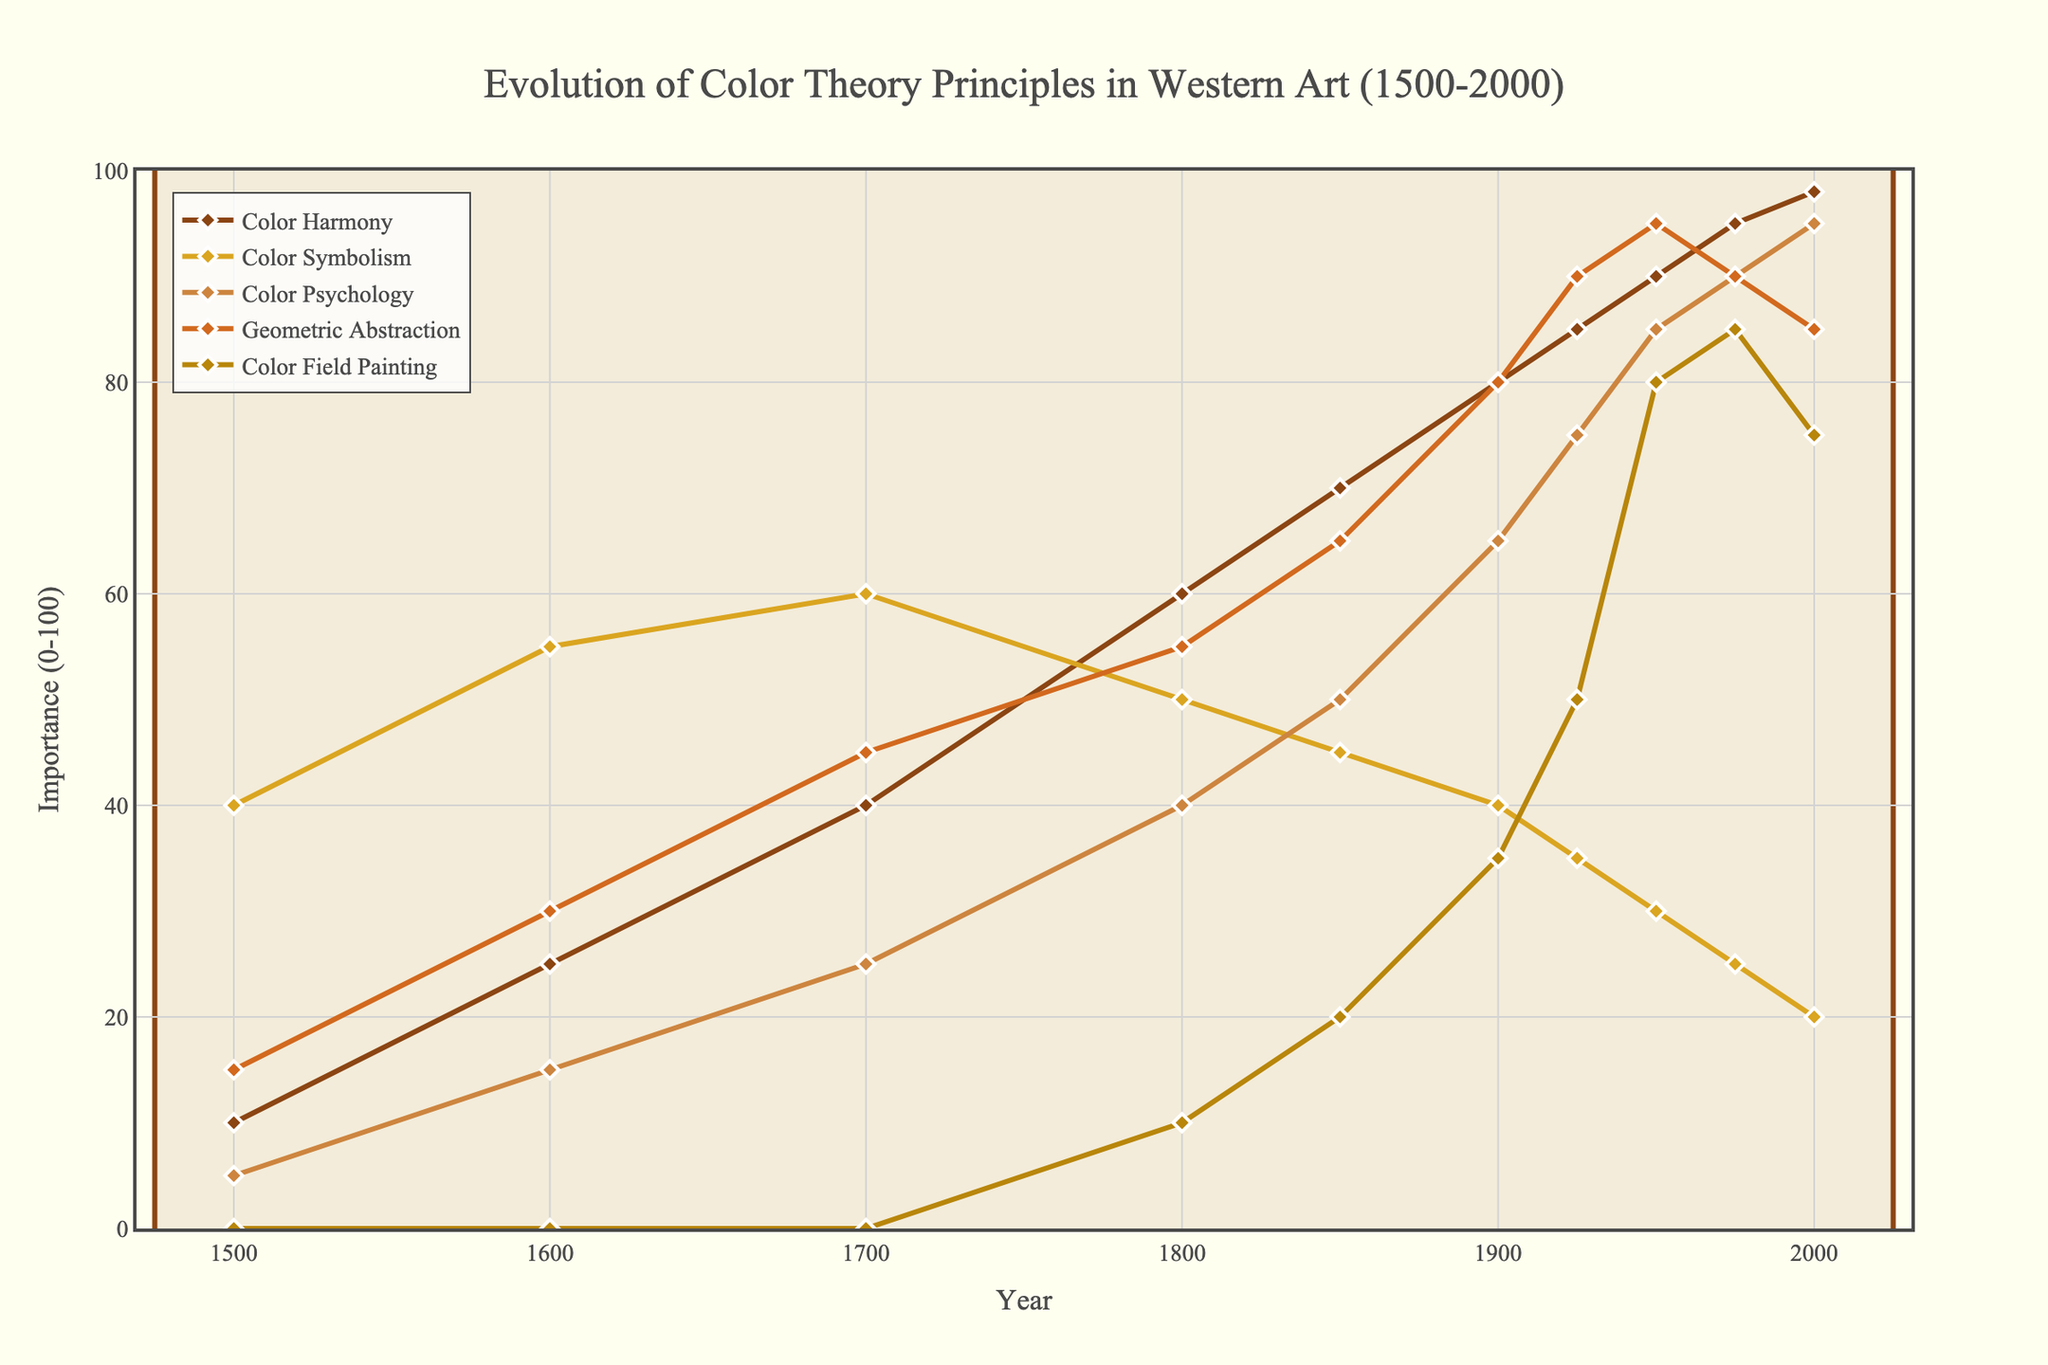What is the earliest year when Color Harmony was more important than Color Symbolism? We need to compare the values of "Color Harmony" and "Color Symbolism" over the years and determine the first instance where Color Harmony surpasses Color Symbolism. According to the figure, Color Harmony first surpasses Color Symbolism in 1800.
Answer: 1800 What was the importance of Geometric Abstraction in 1950? We can simply look at the value of Geometric Abstraction in the year 1950 on the line chart. The value is 95.
Answer: 95 By how much did Color Psychology increase from 1500 to 2000? We need to find the difference between the value of Color Psychology in 2000 and 1500. The values are 95 and 5 respectively. The increase = 95 - 5 = 90.
Answer: 90 Which color theory principle had the highest importance in 1925? Reviewing the chart, the highest point in 1925 is Color Harmony with a value of 85.
Answer: Color Harmony Compare the trend of Color Field Painting and Geometric Abstraction from 1900 to 2000. Which one increased more rapidly? To determine which one increased more rapidly, we observe the gradient of their lines. Color Field Painting starts at 35 and ends at 75, while Geometric Abstraction starts at 80 and ends at 85. The increase in Color Field Painting is 75 - 35 = 40, whereas Geometric Abstraction rises by 85 - 80 = 5. Hence, Color Field Painting increased more rapidly.
Answer: Color Field Painting What was the significance of Color Harmony and Color Psychology in 1600 combined? We sum the importance values of Color Harmony and Color Psychology in 1600. According to the figure, the values are 25 and 15 respectively. The combined significance = 25 + 15 = 40.
Answer: 40 Which principle shows a relative decline in importance from 1800 to 2000? Observing the line chart, we see that Color Symbolism's importance decreases from 50 in 1800 to 20 in 2000.
Answer: Color Symbolism Identify the year when Color Field Painting reaches its maximum importance. The peak of Color Field Painting is in 1975 with a value of 85.
Answer: 1975 What is the average importance of Geometric Abstraction across all measured years? To determine the average, sum all values for Geometric Abstraction and divide by the number of years. The values are 15, 30, 45, 55, 65, 80, 90, 95, 90, 85. Sum = 650, number of years = 10. Average = 650/10 = 65.
Answer: 65 